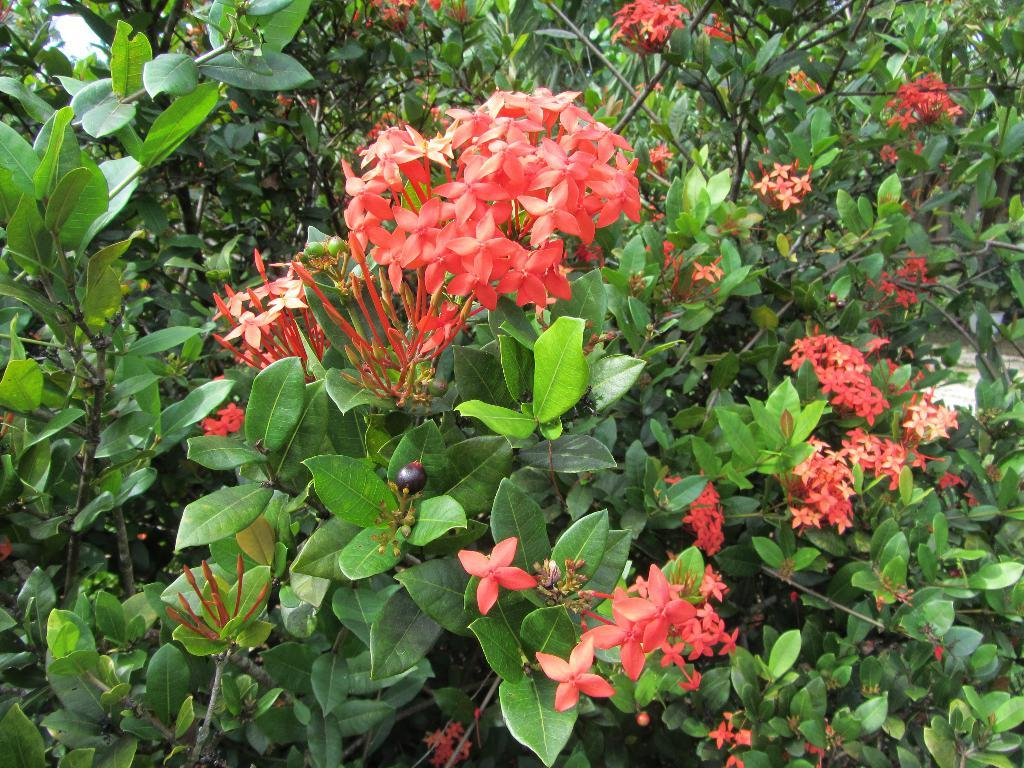What is the main subject of the image? The main subject of the image is a zoomed-in picture of flower plants. What can be observed about the color of the flowers in the image? The flowers are in red color. What type of wound can be seen on the carpenter's hand in the image? There is no carpenter or wound present in the image; it features a zoomed-in picture of red flower plants. 